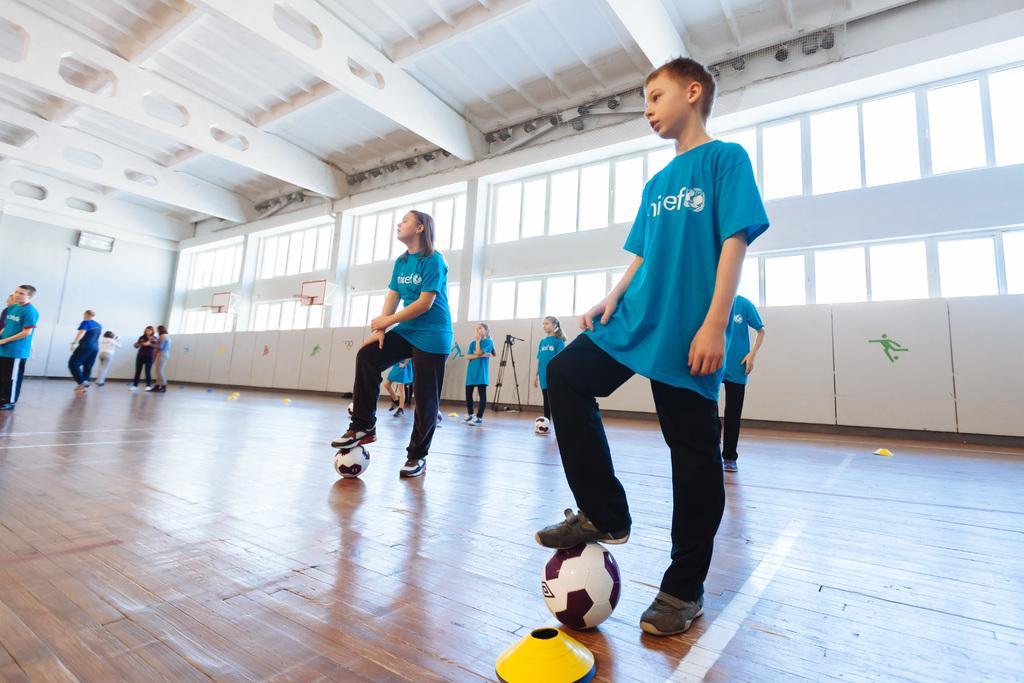Please provide a concise description of this image. In this picture, we can see a group of people standing on the floor and some people are walking and on the floor there are balls and other things. Behind the people there is a wall with windows and lights. 